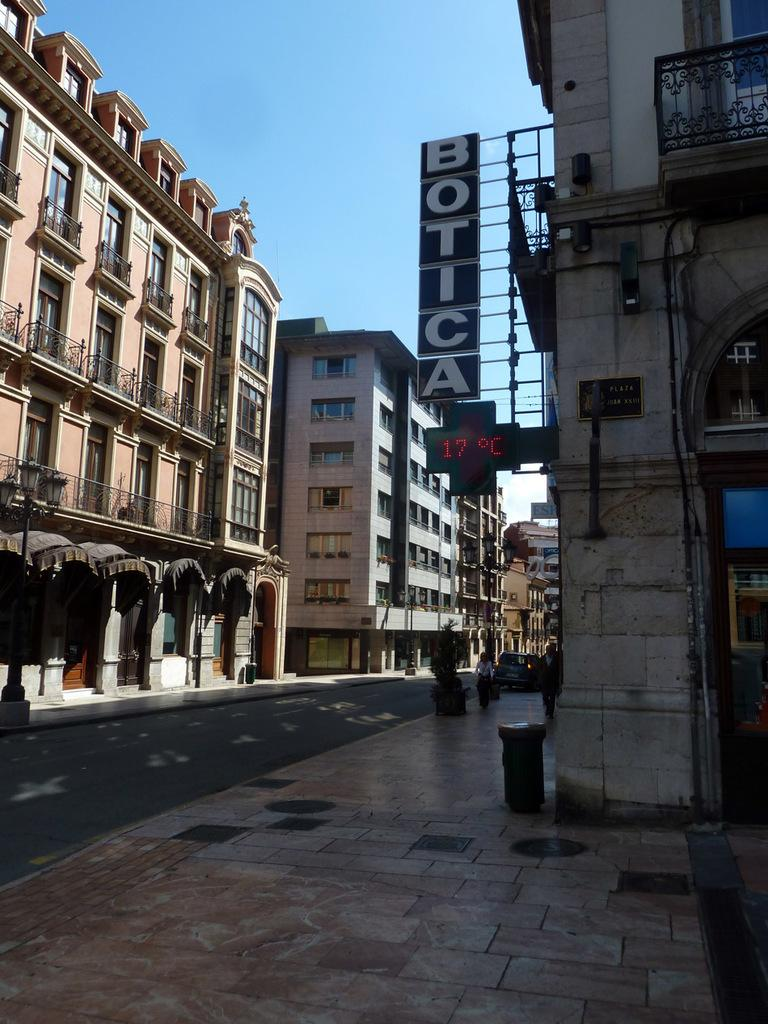What type of structures can be seen in the image? There are buildings in the image. What decorative elements are present in the image? There are banners in the image. What can be observed in the center of the image? There are people standing in the middle of the image. What is visible in the background of the image? There are vehicles on the road in the background of the image. Can you tell me how many times the people in the image jump in unison? There is no indication in the image that the people are jumping or performing any specific action. Where is the spot where the vehicles are parked in the image? The vehicles are not parked; they are moving on the road in the background of the image. 